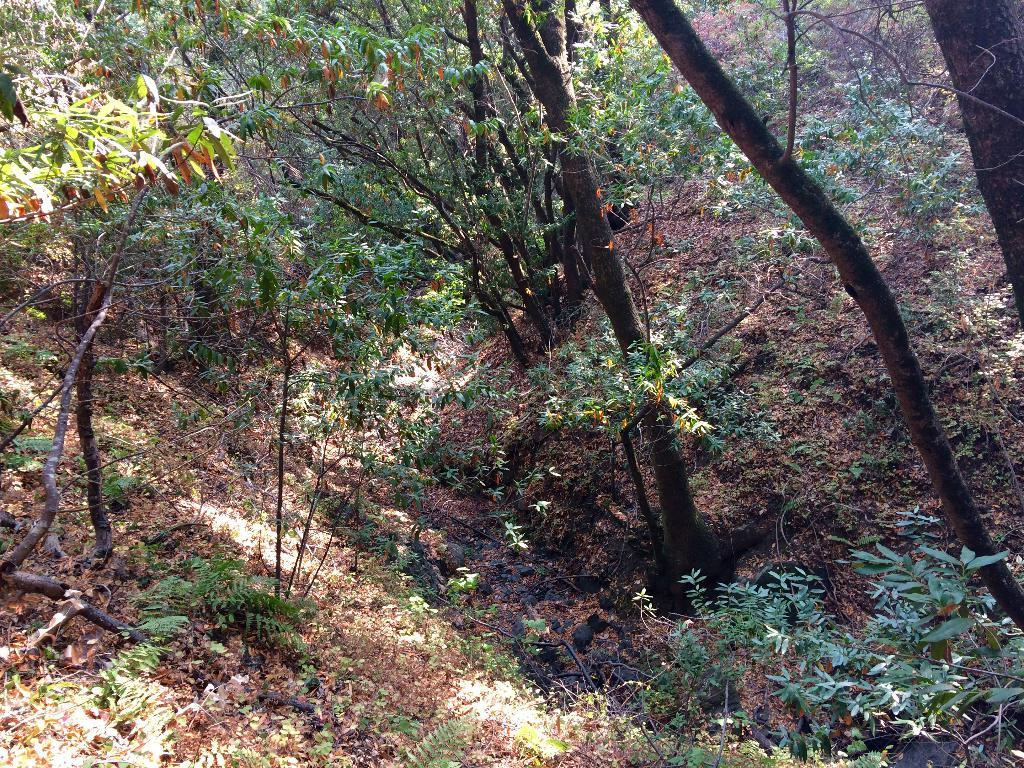What type of vegetation can be seen in the image? There are trees and plants in the image. What is the ground covered with in the image? Grass is visible in the image. Are there any other objects on the ground besides vegetation? Yes, there are other objects on the ground in the image. What news is being reported by the parcel in the image? There is no parcel present in the image, and therefore no news can be reported. 